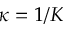<formula> <loc_0><loc_0><loc_500><loc_500>\kappa = 1 / K</formula> 